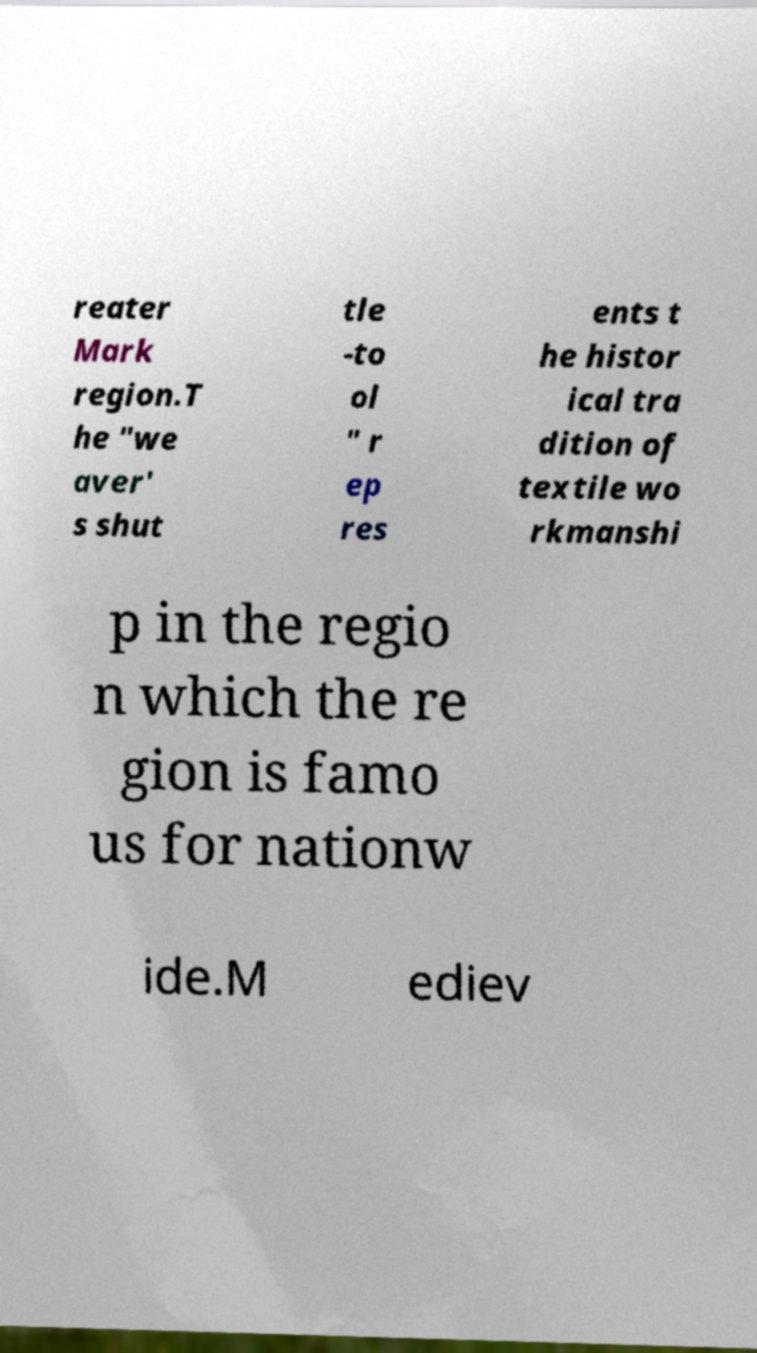Could you extract and type out the text from this image? reater Mark region.T he "we aver' s shut tle -to ol " r ep res ents t he histor ical tra dition of textile wo rkmanshi p in the regio n which the re gion is famo us for nationw ide.M ediev 